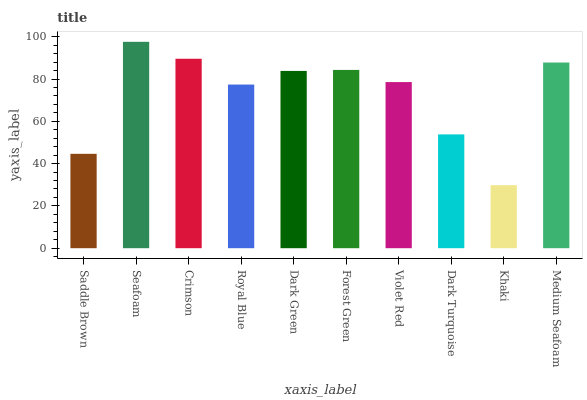Is Khaki the minimum?
Answer yes or no. Yes. Is Seafoam the maximum?
Answer yes or no. Yes. Is Crimson the minimum?
Answer yes or no. No. Is Crimson the maximum?
Answer yes or no. No. Is Seafoam greater than Crimson?
Answer yes or no. Yes. Is Crimson less than Seafoam?
Answer yes or no. Yes. Is Crimson greater than Seafoam?
Answer yes or no. No. Is Seafoam less than Crimson?
Answer yes or no. No. Is Dark Green the high median?
Answer yes or no. Yes. Is Violet Red the low median?
Answer yes or no. Yes. Is Saddle Brown the high median?
Answer yes or no. No. Is Dark Green the low median?
Answer yes or no. No. 